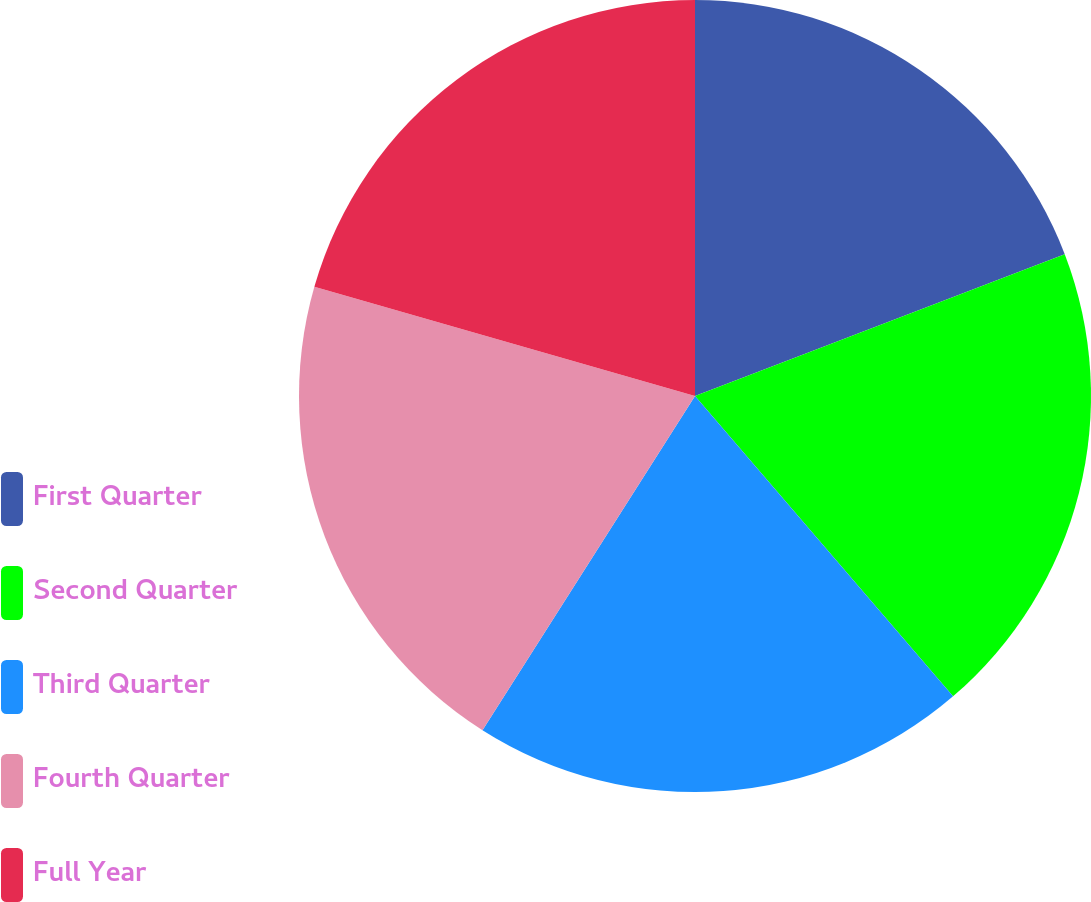<chart> <loc_0><loc_0><loc_500><loc_500><pie_chart><fcel>First Quarter<fcel>Second Quarter<fcel>Third Quarter<fcel>Fourth Quarter<fcel>Full Year<nl><fcel>19.17%<fcel>19.53%<fcel>20.31%<fcel>20.43%<fcel>20.55%<nl></chart> 